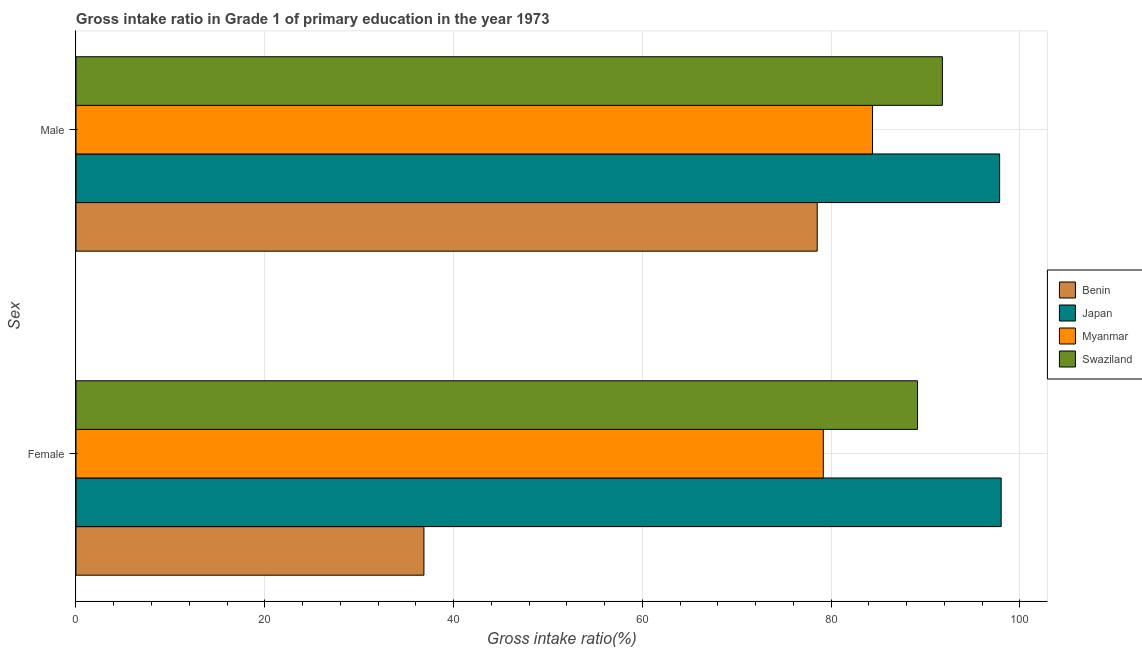How many groups of bars are there?
Offer a very short reply. 2. How many bars are there on the 1st tick from the top?
Offer a terse response. 4. How many bars are there on the 2nd tick from the bottom?
Make the answer very short. 4. What is the label of the 2nd group of bars from the top?
Make the answer very short. Female. What is the gross intake ratio(male) in Benin?
Your answer should be very brief. 78.53. Across all countries, what is the maximum gross intake ratio(male)?
Your answer should be compact. 97.86. Across all countries, what is the minimum gross intake ratio(male)?
Your answer should be compact. 78.53. In which country was the gross intake ratio(female) maximum?
Your answer should be very brief. Japan. In which country was the gross intake ratio(male) minimum?
Your answer should be compact. Benin. What is the total gross intake ratio(female) in the graph?
Your response must be concise. 303.21. What is the difference between the gross intake ratio(male) in Japan and that in Benin?
Offer a very short reply. 19.33. What is the difference between the gross intake ratio(male) in Myanmar and the gross intake ratio(female) in Swaziland?
Your answer should be very brief. -4.77. What is the average gross intake ratio(male) per country?
Offer a terse response. 88.14. What is the difference between the gross intake ratio(male) and gross intake ratio(female) in Swaziland?
Provide a succinct answer. 2.63. In how many countries, is the gross intake ratio(male) greater than 52 %?
Your answer should be compact. 4. What is the ratio of the gross intake ratio(male) in Swaziland to that in Japan?
Keep it short and to the point. 0.94. Is the gross intake ratio(male) in Benin less than that in Myanmar?
Ensure brevity in your answer.  Yes. In how many countries, is the gross intake ratio(female) greater than the average gross intake ratio(female) taken over all countries?
Your answer should be very brief. 3. What does the 4th bar from the top in Female represents?
Make the answer very short. Benin. What does the 1st bar from the bottom in Male represents?
Ensure brevity in your answer.  Benin. How many bars are there?
Offer a very short reply. 8. Are all the bars in the graph horizontal?
Keep it short and to the point. Yes. How many countries are there in the graph?
Provide a short and direct response. 4. Are the values on the major ticks of X-axis written in scientific E-notation?
Give a very brief answer. No. Does the graph contain any zero values?
Make the answer very short. No. Does the graph contain grids?
Keep it short and to the point. Yes. How are the legend labels stacked?
Your answer should be very brief. Vertical. What is the title of the graph?
Your answer should be compact. Gross intake ratio in Grade 1 of primary education in the year 1973. Does "St. Vincent and the Grenadines" appear as one of the legend labels in the graph?
Provide a short and direct response. No. What is the label or title of the X-axis?
Offer a terse response. Gross intake ratio(%). What is the label or title of the Y-axis?
Provide a short and direct response. Sex. What is the Gross intake ratio(%) of Benin in Female?
Your answer should be compact. 36.86. What is the Gross intake ratio(%) of Japan in Female?
Give a very brief answer. 98.02. What is the Gross intake ratio(%) in Myanmar in Female?
Your response must be concise. 79.18. What is the Gross intake ratio(%) of Swaziland in Female?
Provide a short and direct response. 89.16. What is the Gross intake ratio(%) in Benin in Male?
Make the answer very short. 78.53. What is the Gross intake ratio(%) in Japan in Male?
Ensure brevity in your answer.  97.86. What is the Gross intake ratio(%) in Myanmar in Male?
Provide a short and direct response. 84.39. What is the Gross intake ratio(%) of Swaziland in Male?
Your answer should be very brief. 91.79. Across all Sex, what is the maximum Gross intake ratio(%) in Benin?
Offer a very short reply. 78.53. Across all Sex, what is the maximum Gross intake ratio(%) in Japan?
Provide a succinct answer. 98.02. Across all Sex, what is the maximum Gross intake ratio(%) in Myanmar?
Provide a short and direct response. 84.39. Across all Sex, what is the maximum Gross intake ratio(%) of Swaziland?
Make the answer very short. 91.79. Across all Sex, what is the minimum Gross intake ratio(%) in Benin?
Your answer should be compact. 36.86. Across all Sex, what is the minimum Gross intake ratio(%) of Japan?
Your response must be concise. 97.86. Across all Sex, what is the minimum Gross intake ratio(%) in Myanmar?
Your answer should be compact. 79.18. Across all Sex, what is the minimum Gross intake ratio(%) of Swaziland?
Ensure brevity in your answer.  89.16. What is the total Gross intake ratio(%) of Benin in the graph?
Offer a terse response. 115.39. What is the total Gross intake ratio(%) of Japan in the graph?
Give a very brief answer. 195.87. What is the total Gross intake ratio(%) of Myanmar in the graph?
Ensure brevity in your answer.  163.57. What is the total Gross intake ratio(%) in Swaziland in the graph?
Provide a short and direct response. 180.95. What is the difference between the Gross intake ratio(%) of Benin in Female and that in Male?
Provide a short and direct response. -41.67. What is the difference between the Gross intake ratio(%) in Japan in Female and that in Male?
Provide a short and direct response. 0.16. What is the difference between the Gross intake ratio(%) of Myanmar in Female and that in Male?
Your answer should be very brief. -5.21. What is the difference between the Gross intake ratio(%) of Swaziland in Female and that in Male?
Provide a succinct answer. -2.63. What is the difference between the Gross intake ratio(%) in Benin in Female and the Gross intake ratio(%) in Japan in Male?
Your answer should be compact. -60.99. What is the difference between the Gross intake ratio(%) in Benin in Female and the Gross intake ratio(%) in Myanmar in Male?
Ensure brevity in your answer.  -47.53. What is the difference between the Gross intake ratio(%) in Benin in Female and the Gross intake ratio(%) in Swaziland in Male?
Provide a short and direct response. -54.93. What is the difference between the Gross intake ratio(%) of Japan in Female and the Gross intake ratio(%) of Myanmar in Male?
Ensure brevity in your answer.  13.63. What is the difference between the Gross intake ratio(%) of Japan in Female and the Gross intake ratio(%) of Swaziland in Male?
Your answer should be very brief. 6.23. What is the difference between the Gross intake ratio(%) of Myanmar in Female and the Gross intake ratio(%) of Swaziland in Male?
Your response must be concise. -12.61. What is the average Gross intake ratio(%) of Benin per Sex?
Your answer should be very brief. 57.7. What is the average Gross intake ratio(%) in Japan per Sex?
Keep it short and to the point. 97.94. What is the average Gross intake ratio(%) of Myanmar per Sex?
Your response must be concise. 81.78. What is the average Gross intake ratio(%) in Swaziland per Sex?
Make the answer very short. 90.47. What is the difference between the Gross intake ratio(%) of Benin and Gross intake ratio(%) of Japan in Female?
Provide a short and direct response. -61.16. What is the difference between the Gross intake ratio(%) of Benin and Gross intake ratio(%) of Myanmar in Female?
Ensure brevity in your answer.  -42.31. What is the difference between the Gross intake ratio(%) of Benin and Gross intake ratio(%) of Swaziland in Female?
Your answer should be very brief. -52.3. What is the difference between the Gross intake ratio(%) in Japan and Gross intake ratio(%) in Myanmar in Female?
Your answer should be compact. 18.84. What is the difference between the Gross intake ratio(%) of Japan and Gross intake ratio(%) of Swaziland in Female?
Give a very brief answer. 8.86. What is the difference between the Gross intake ratio(%) in Myanmar and Gross intake ratio(%) in Swaziland in Female?
Keep it short and to the point. -9.98. What is the difference between the Gross intake ratio(%) of Benin and Gross intake ratio(%) of Japan in Male?
Provide a succinct answer. -19.33. What is the difference between the Gross intake ratio(%) of Benin and Gross intake ratio(%) of Myanmar in Male?
Ensure brevity in your answer.  -5.86. What is the difference between the Gross intake ratio(%) of Benin and Gross intake ratio(%) of Swaziland in Male?
Keep it short and to the point. -13.26. What is the difference between the Gross intake ratio(%) of Japan and Gross intake ratio(%) of Myanmar in Male?
Give a very brief answer. 13.47. What is the difference between the Gross intake ratio(%) of Japan and Gross intake ratio(%) of Swaziland in Male?
Offer a very short reply. 6.06. What is the difference between the Gross intake ratio(%) of Myanmar and Gross intake ratio(%) of Swaziland in Male?
Make the answer very short. -7.4. What is the ratio of the Gross intake ratio(%) in Benin in Female to that in Male?
Keep it short and to the point. 0.47. What is the ratio of the Gross intake ratio(%) in Myanmar in Female to that in Male?
Give a very brief answer. 0.94. What is the ratio of the Gross intake ratio(%) in Swaziland in Female to that in Male?
Offer a very short reply. 0.97. What is the difference between the highest and the second highest Gross intake ratio(%) in Benin?
Your response must be concise. 41.67. What is the difference between the highest and the second highest Gross intake ratio(%) of Japan?
Your answer should be very brief. 0.16. What is the difference between the highest and the second highest Gross intake ratio(%) of Myanmar?
Offer a terse response. 5.21. What is the difference between the highest and the second highest Gross intake ratio(%) in Swaziland?
Give a very brief answer. 2.63. What is the difference between the highest and the lowest Gross intake ratio(%) of Benin?
Offer a terse response. 41.67. What is the difference between the highest and the lowest Gross intake ratio(%) in Japan?
Make the answer very short. 0.16. What is the difference between the highest and the lowest Gross intake ratio(%) of Myanmar?
Give a very brief answer. 5.21. What is the difference between the highest and the lowest Gross intake ratio(%) in Swaziland?
Offer a very short reply. 2.63. 